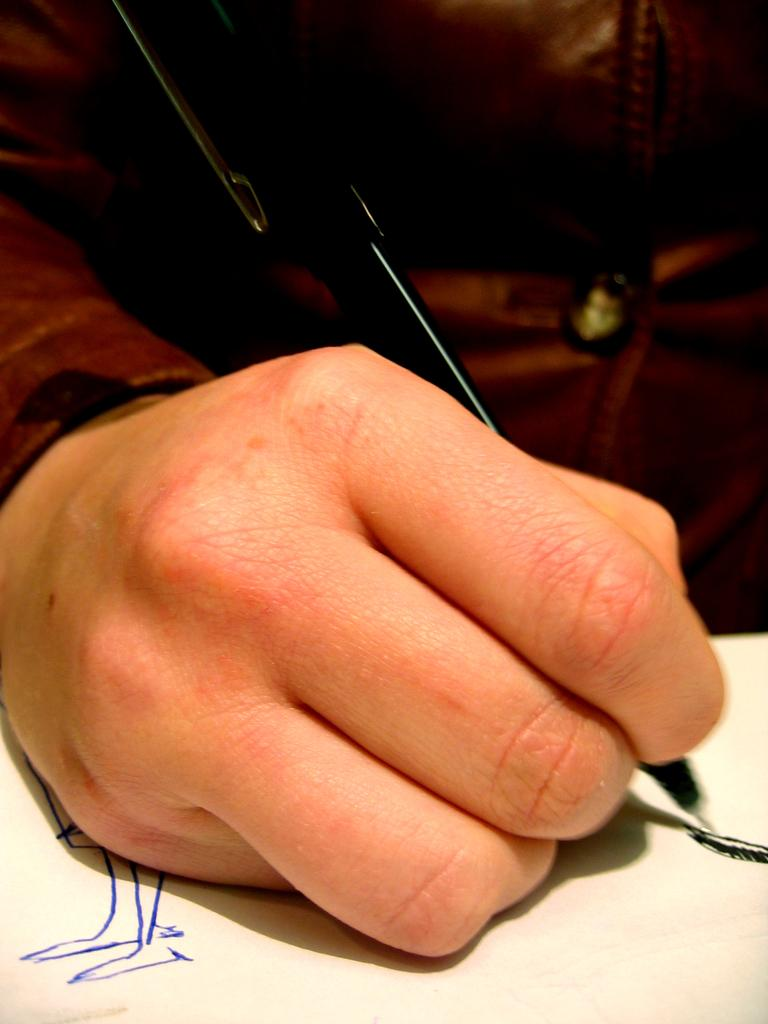What is the main subject of the image? There is a person in the image. What is the person holding in the image? The person is holding a pen. What is the person doing with the pen? The person is writing on a paper. What type of grass is growing on the calendar in the image? There is no calendar or grass present in the image; it features a person holding a pen and writing on a paper. 